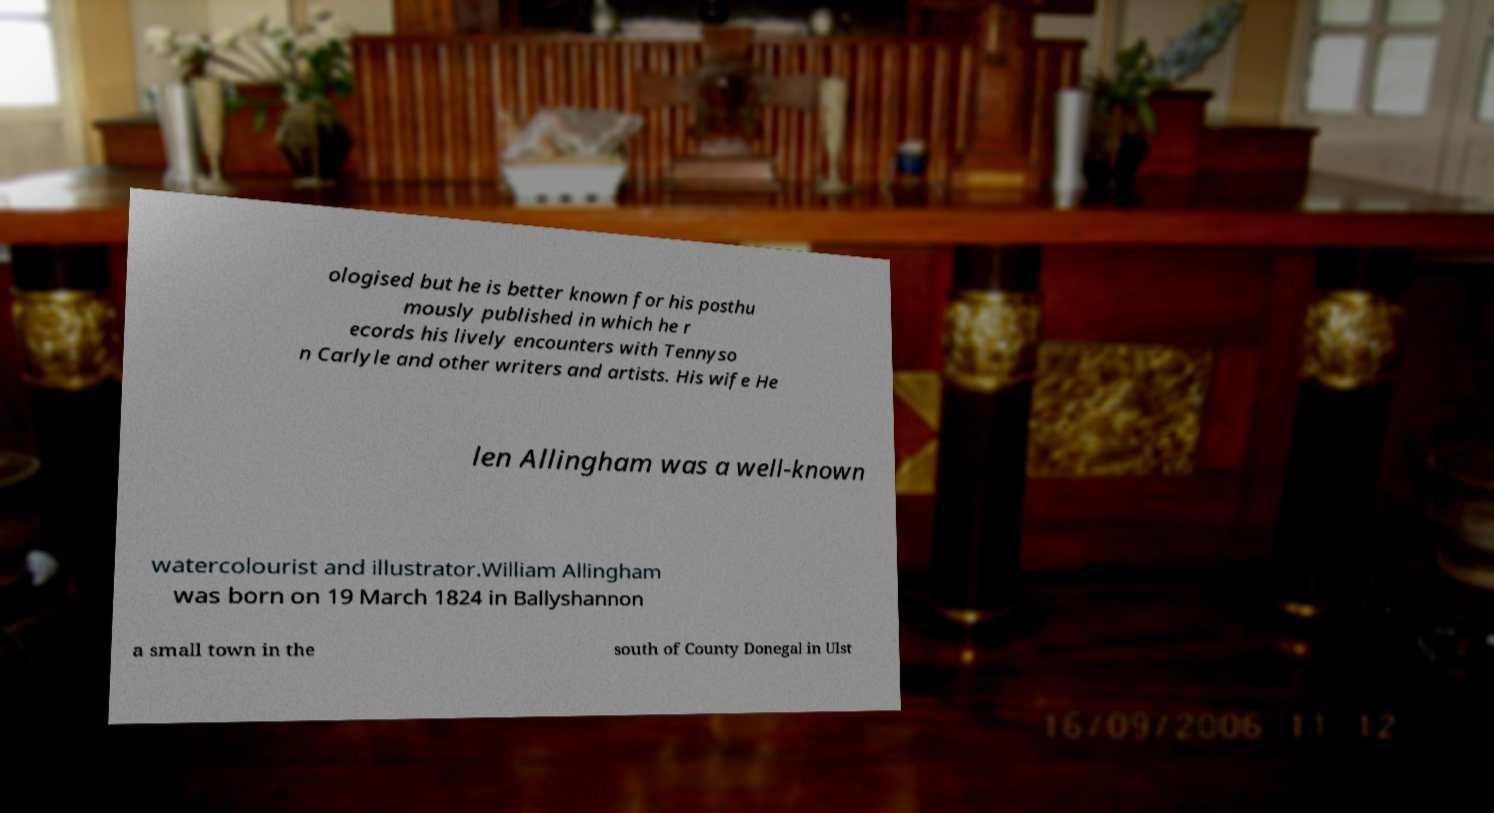Could you assist in decoding the text presented in this image and type it out clearly? ologised but he is better known for his posthu mously published in which he r ecords his lively encounters with Tennyso n Carlyle and other writers and artists. His wife He len Allingham was a well-known watercolourist and illustrator.William Allingham was born on 19 March 1824 in Ballyshannon a small town in the south of County Donegal in Ulst 